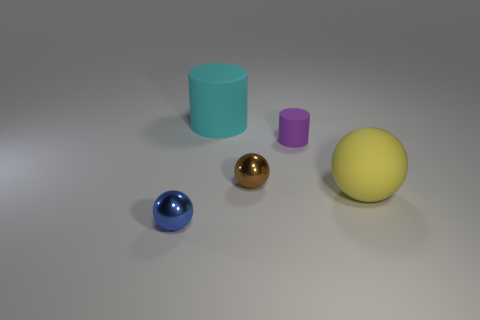What material is the cyan thing?
Your answer should be very brief. Rubber. What number of metallic things are to the left of the large yellow sphere?
Your response must be concise. 2. Does the big rubber cylinder have the same color as the large sphere?
Give a very brief answer. No. Are there more big yellow matte spheres than big metallic cylinders?
Make the answer very short. Yes. There is a object that is both to the left of the brown shiny sphere and behind the blue metallic thing; how big is it?
Provide a succinct answer. Large. Are the small sphere to the right of the small blue metal sphere and the big sphere that is on the right side of the small blue sphere made of the same material?
Give a very brief answer. No. The yellow thing that is the same size as the cyan cylinder is what shape?
Provide a short and direct response. Sphere. Is the number of big cyan cubes less than the number of big yellow spheres?
Provide a succinct answer. Yes. Are there any small balls that are to the left of the rubber object behind the small purple matte thing?
Keep it short and to the point. Yes. Are there any big spheres that are to the right of the small cylinder behind the small thing on the left side of the big cyan cylinder?
Keep it short and to the point. Yes. 